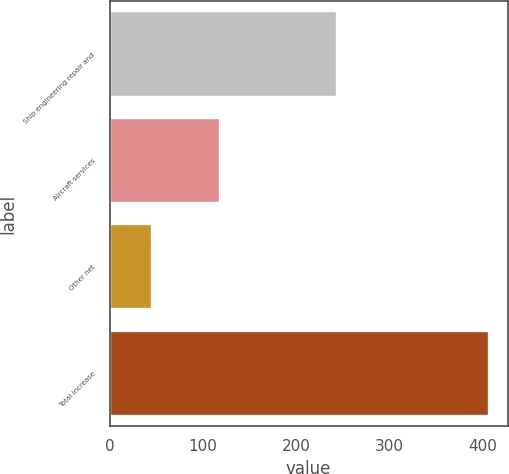Convert chart to OTSL. <chart><loc_0><loc_0><loc_500><loc_500><bar_chart><fcel>Ship engineering repair and<fcel>Aircraft services<fcel>Other net<fcel>Total increase<nl><fcel>243<fcel>118<fcel>45<fcel>406<nl></chart> 